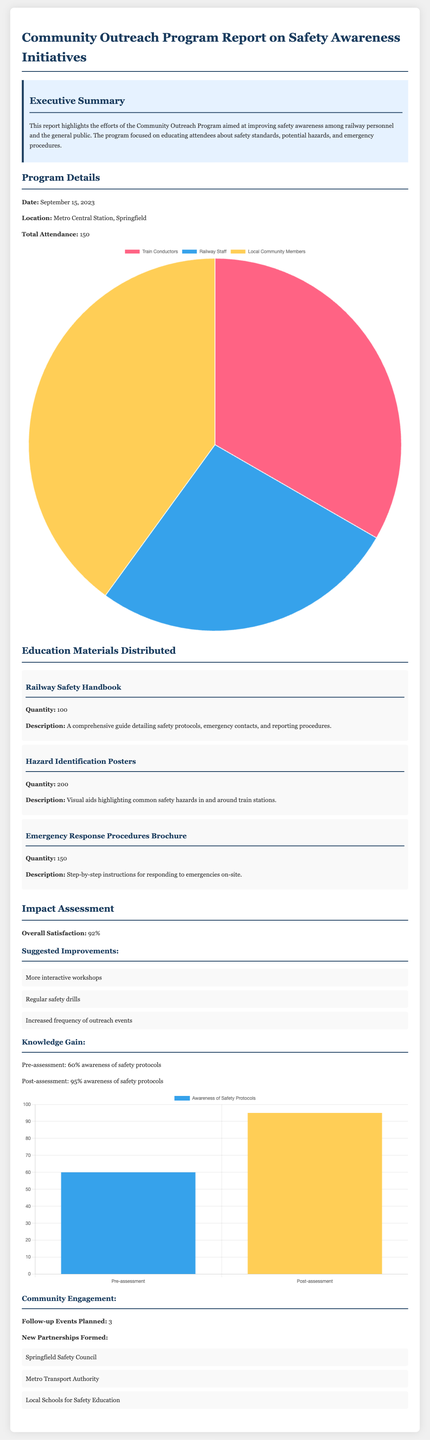What was the date of the program? The date of the program is explicitly mentioned in the report.
Answer: September 15, 2023 What was the total attendance for the outreach program? The report provides the total attendance figure.
Answer: 150 How many Railway Safety Handbooks were distributed? The quantity of each educational material is listed in the document.
Answer: 100 What was the overall satisfaction percentage reported? Overall satisfaction is noted as a specific percentage in the impact assessment section.
Answer: 92% What is the awareness percentage of safety protocols after the program? The post-assessment awareness percentage is clearly stated in the impact assessment.
Answer: 95% Which organization was formed as a new partnership? The new partnership formed is mentioned in the community engagement section.
Answer: Springfield Safety Council What are the suggested improvements in the report? Suggested improvements are listed bullet points in the impact assessment.
Answer: More interactive workshops How many follow-up events are planned? The number of follow-up events is indicated in the community engagement section.
Answer: 3 What type of chart shows participant demographics? The document describes the type of chart used to present the demographics.
Answer: Pie What was the knowledge gain in terms of safety protocol awareness from pre-assessment to post-assessment? Knowledge gain is illustrated by providing the pre- and post-assessment figures.
Answer: 35% 